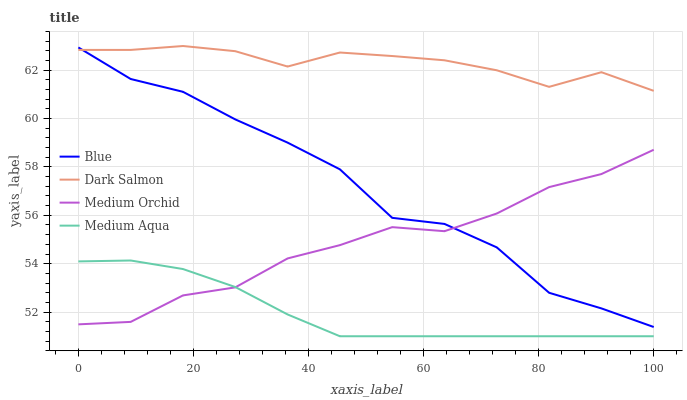Does Medium Orchid have the minimum area under the curve?
Answer yes or no. No. Does Medium Orchid have the maximum area under the curve?
Answer yes or no. No. Is Medium Orchid the smoothest?
Answer yes or no. No. Is Medium Orchid the roughest?
Answer yes or no. No. Does Medium Orchid have the lowest value?
Answer yes or no. No. Does Medium Orchid have the highest value?
Answer yes or no. No. Is Medium Aqua less than Blue?
Answer yes or no. Yes. Is Dark Salmon greater than Medium Orchid?
Answer yes or no. Yes. Does Medium Aqua intersect Blue?
Answer yes or no. No. 